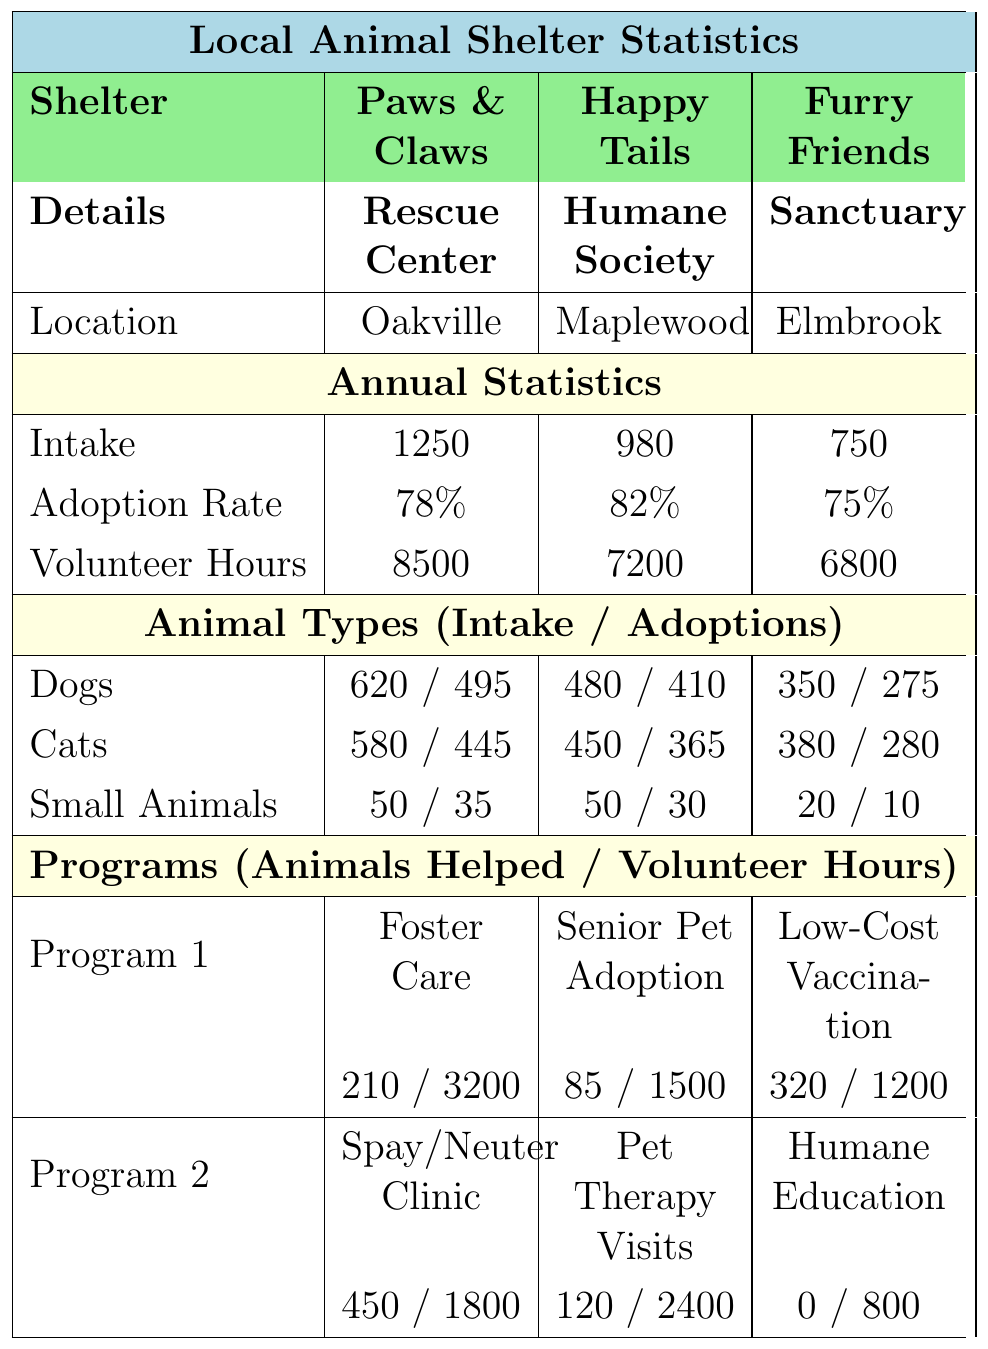What is the total intake of animals at Paws & Claws Rescue Center? The table shows that the intake at Paws & Claws Rescue Center is listed as 1250.
Answer: 1250 What is the adoption rate for Happy Tails Humane Society? According to the table, the adoption rate for Happy Tails Humane Society is 82%.
Answer: 82% How many volunteer hours were logged at Furry Friends Sanctuary? The table indicates that Furry Friends Sanctuary logged 6800 volunteer hours.
Answer: 6800 Which shelter has the highest adoption rate? Comparing the adoption rates listed in the table: Paws & Claws (78%), Happy Tails (82%), and Furry Friends (75%), Happy Tails has the highest rate at 82%.
Answer: Happy Tails Humane Society How many dogs were adopted at Paws & Claws Rescue Center? The table states that 495 dogs were adopted at Paws & Claws Rescue Center.
Answer: 495 What is the difference in intake between Happy Tails and Furry Friends? The intake for Happy Tails is 980, and for Furry Friends, it is 750. The difference is 980 - 750 = 230.
Answer: 230 If you combine the volunteer hours of all three shelters, how many hours are recorded in total? The volunteer hours for each shelter are: Paws & Claws (8500), Happy Tails (7200), and Furry Friends (6800). Summing these gives 8500 + 7200 + 6800 = 22500 hours.
Answer: 22500 What percentage of dog intakes at Furry Friends were adopted? Furry Friends had 350 dog intakes and 275 adoptions. The percentage adopted is (275 / 350) * 100 = 78.57%.
Answer: 78.57% Which type of animal had the lowest number of adoptions across all shelters? By examining the adoptions: 495 dogs, 445 cats, and 35 small animals from Paws & Claws; 410 dogs, 365 cats, and 30 small animals from Happy Tails; and 275 dogs, 280 cats, and 10 small animals from Furry Friends, the lowest is 10 small animals from Furry Friends.
Answer: Small animals Were more cats or dogs adopted at Happy Tails Humane Society? At Happy Tails, 410 dogs were adopted compared to 365 cats. Since 410 is greater than 365, more dogs were adopted.
Answer: Dogs 